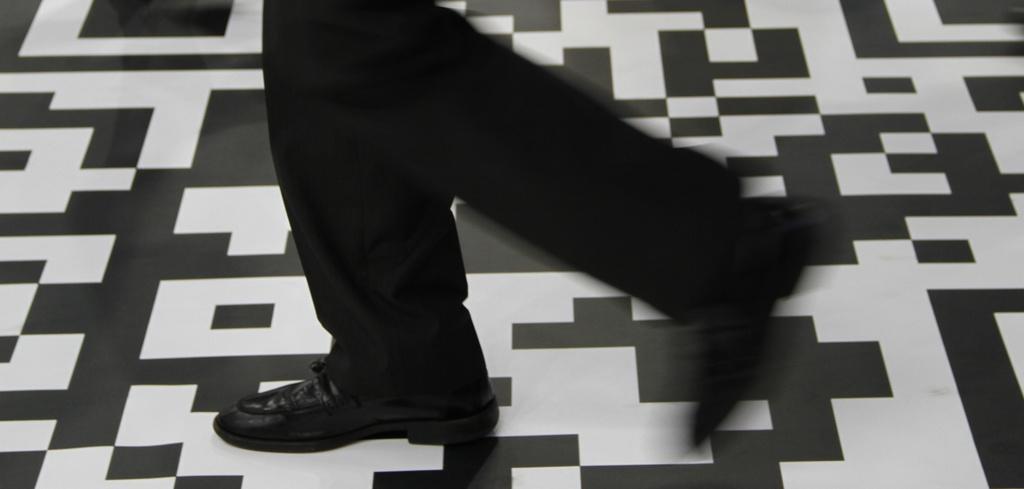How would you summarize this image in a sentence or two? In this image we can see person's legs on the floor. 